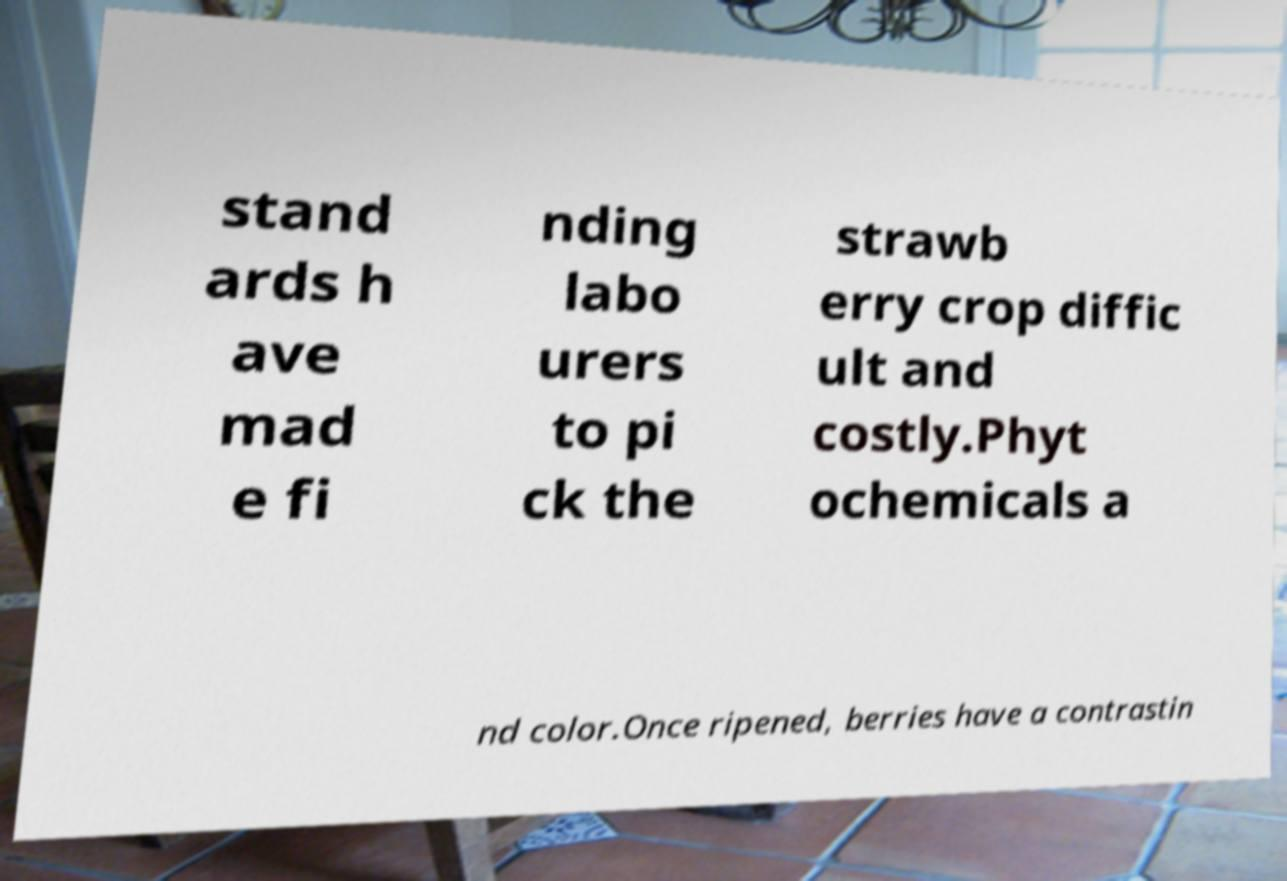There's text embedded in this image that I need extracted. Can you transcribe it verbatim? stand ards h ave mad e fi nding labo urers to pi ck the strawb erry crop diffic ult and costly.Phyt ochemicals a nd color.Once ripened, berries have a contrastin 